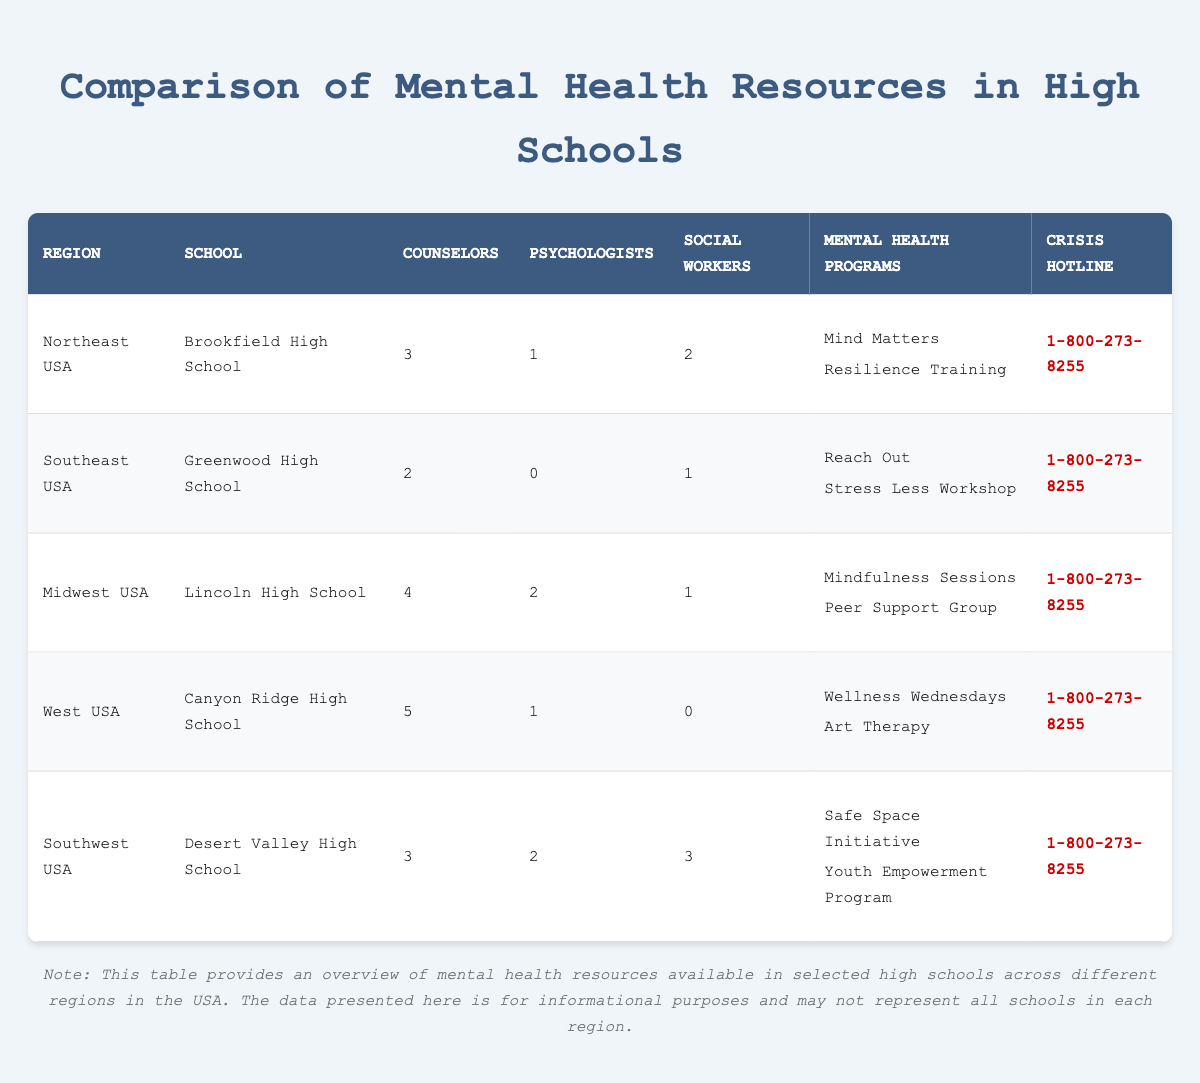What is the total number of counselors in Desert Valley High School? The table indicates that Desert Valley High School has 3 counselors listed. Therefore, the total number of counselors in Desert Valley High School is simply 3.
Answer: 3 Which region has the highest number of psychologists? By examining the table, Lincoln High School in the Midwest USA and Desert Valley High School in the Southwest USA both have 2 psychologists. This is the highest number of psychologists listed among the schools.
Answer: Midwest USA and Southwest USA Is Canyon Ridge High School located in the Northeast USA region? The table shows that Canyon Ridge High School is located in the West USA region, not the Northeast USA. Therefore, the statement is false.
Answer: No How many total mental health professionals (counselors, psychologists, and social workers) are there in Lincoln High School? Lincoln High School has 4 counselors, 2 psychologists, and 1 social worker. Adding these together gives: 4 + 2 + 1 = 7. So, there are 7 mental health professionals in total.
Answer: 7 Which high school has the least number of social workers? Looking at the table, Canyon Ridge High School shows 0 social workers, while all other schools have at least 1 social worker. Thus, Canyon Ridge High School has the least number.
Answer: Canyon Ridge High School What is the average number of counselors across all schools? The number of counselors at each school is: Brookfield (3), Greenwood (2), Lincoln (4), Canyon Ridge (5), Desert Valley (3). The total is 3 + 2 + 4 + 5 + 3 = 17. Since there are 5 schools, we divide the total by 5 to find the average: 17/5 = 3.4.
Answer: 3.4 Does every school offer a mental health program? Checking the table, all schools have at least one mental health program listed. Therefore, the statement that every school offers a mental health program is true.
Answer: Yes What is the difference in the number of counselors between the school with the most and the least counselors? The school with the most counselors is Canyon Ridge High School with 5 counselors, while Greenwood High School has the least with 2 counselors. The difference is calculated as 5 - 2 = 3.
Answer: 3 